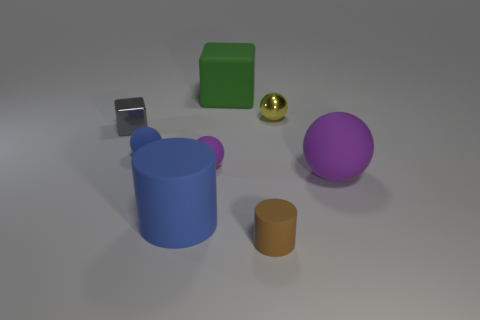Subtract all gray balls. Subtract all gray cylinders. How many balls are left? 4 Add 2 red blocks. How many objects exist? 10 Subtract all cubes. How many objects are left? 6 Add 4 tiny blue metal cylinders. How many tiny blue metal cylinders exist? 4 Subtract 0 brown blocks. How many objects are left? 8 Subtract all large purple rubber things. Subtract all tiny yellow things. How many objects are left? 6 Add 3 tiny gray things. How many tiny gray things are left? 4 